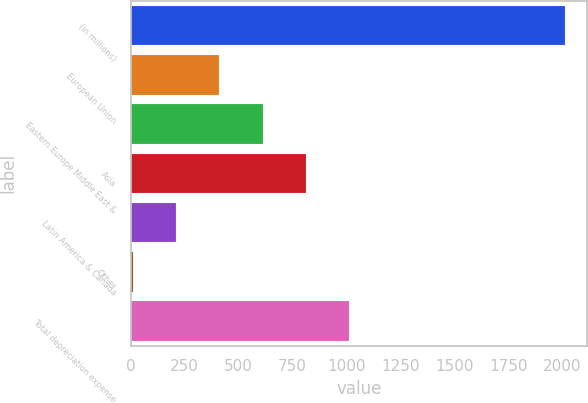Convert chart. <chart><loc_0><loc_0><loc_500><loc_500><bar_chart><fcel>(in millions)<fcel>European Union<fcel>Eastern Europe Middle East &<fcel>Asia<fcel>Latin America & Canada<fcel>Other<fcel>Total depreciation expense<nl><fcel>2013<fcel>410.6<fcel>610.9<fcel>811.2<fcel>210.3<fcel>10<fcel>1011.5<nl></chart> 